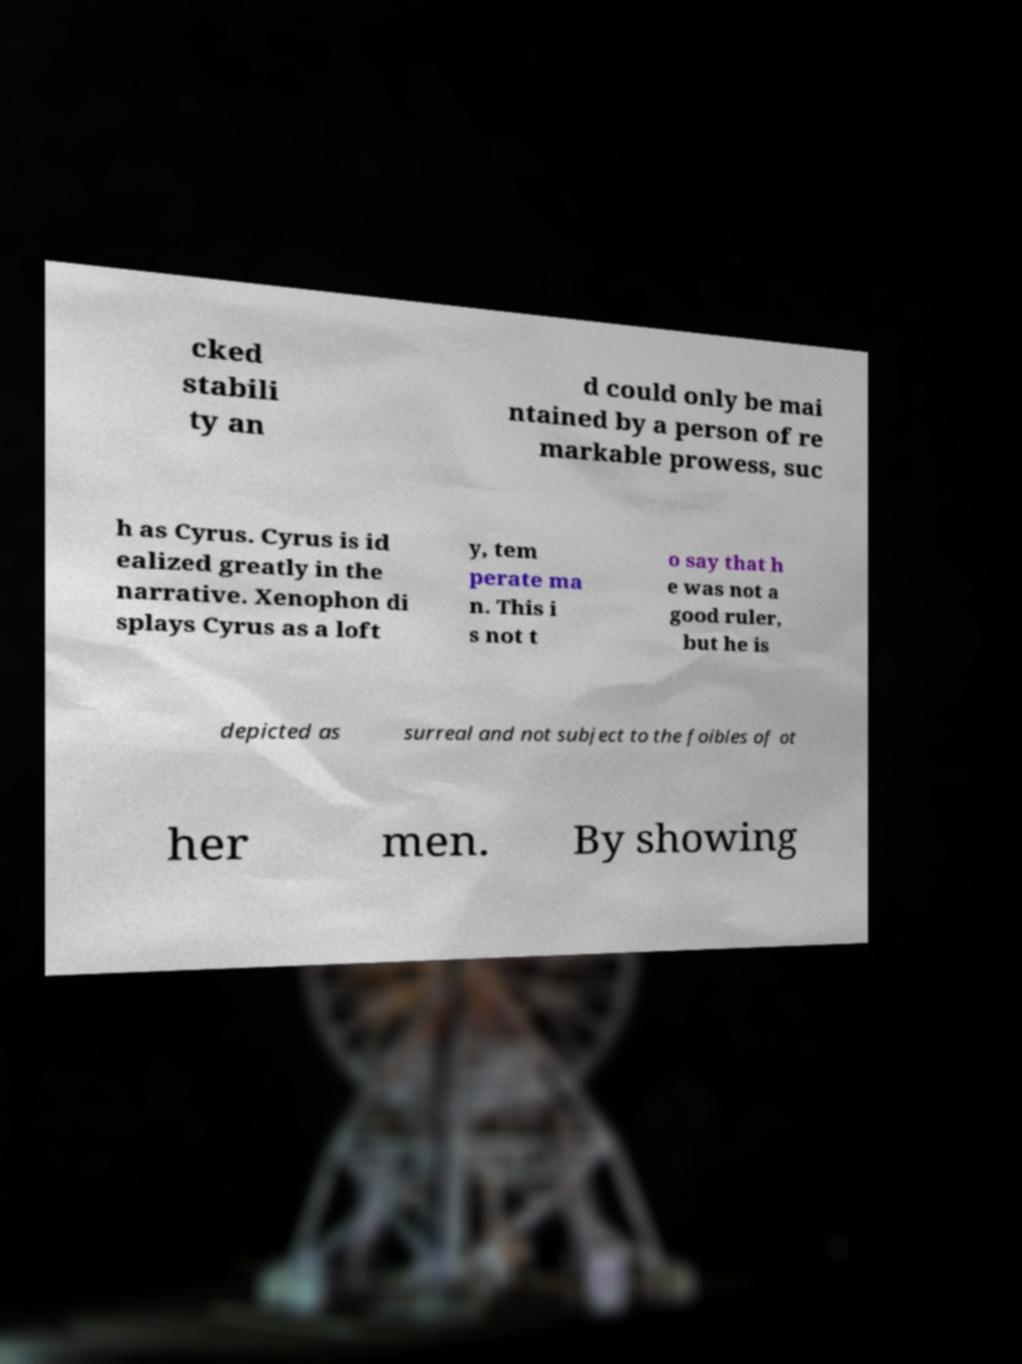Could you extract and type out the text from this image? cked stabili ty an d could only be mai ntained by a person of re markable prowess, suc h as Cyrus. Cyrus is id ealized greatly in the narrative. Xenophon di splays Cyrus as a loft y, tem perate ma n. This i s not t o say that h e was not a good ruler, but he is depicted as surreal and not subject to the foibles of ot her men. By showing 